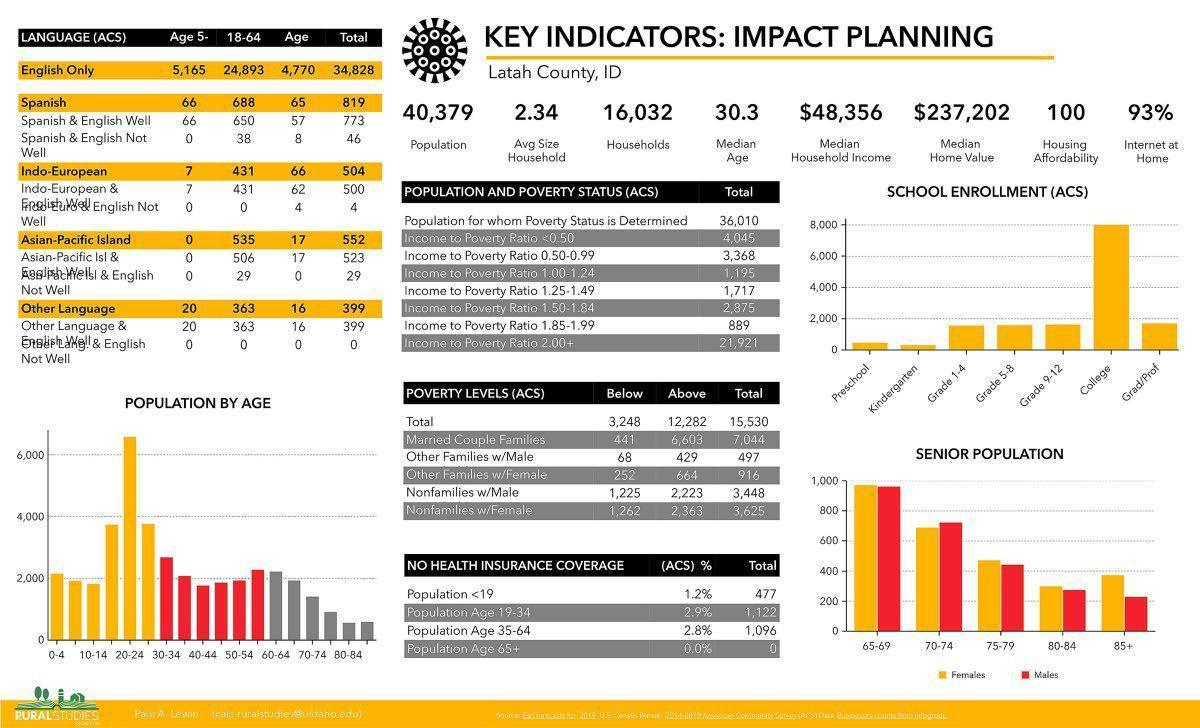What is the median home value?
Answer the question with a short phrase. $237,202 What is the number of females of age group 80-84 in the senior population? 300 What is the number of households? 16,032 Which all grades have the same number of school enrollments? Grade 1-4, Grade 5-8, Grade 9-12 What is the median age? 30.3 